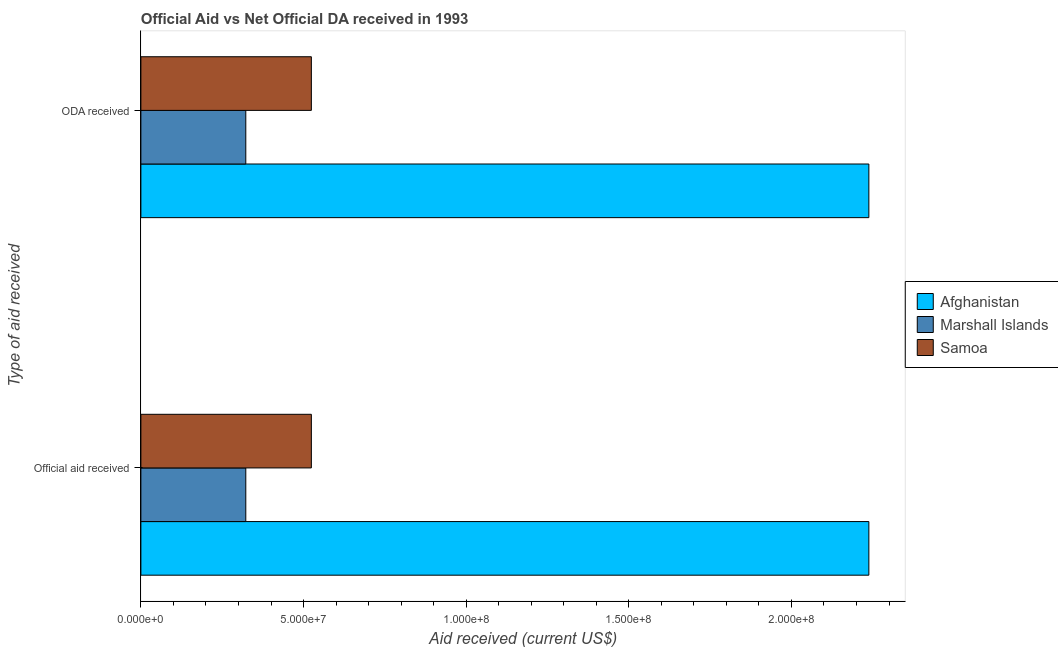How many different coloured bars are there?
Ensure brevity in your answer.  3. Are the number of bars per tick equal to the number of legend labels?
Your answer should be compact. Yes. How many bars are there on the 2nd tick from the bottom?
Ensure brevity in your answer.  3. What is the label of the 2nd group of bars from the top?
Your response must be concise. Official aid received. What is the oda received in Samoa?
Give a very brief answer. 5.24e+07. Across all countries, what is the maximum oda received?
Give a very brief answer. 2.24e+08. Across all countries, what is the minimum official aid received?
Ensure brevity in your answer.  3.22e+07. In which country was the oda received maximum?
Provide a succinct answer. Afghanistan. In which country was the oda received minimum?
Give a very brief answer. Marshall Islands. What is the total official aid received in the graph?
Ensure brevity in your answer.  3.08e+08. What is the difference between the official aid received in Marshall Islands and that in Afghanistan?
Your answer should be compact. -1.92e+08. What is the difference between the oda received in Afghanistan and the official aid received in Marshall Islands?
Your response must be concise. 1.92e+08. What is the average official aid received per country?
Your answer should be compact. 1.03e+08. What is the difference between the official aid received and oda received in Samoa?
Offer a very short reply. 0. In how many countries, is the oda received greater than 30000000 US$?
Provide a succinct answer. 3. What is the ratio of the official aid received in Marshall Islands to that in Afghanistan?
Give a very brief answer. 0.14. In how many countries, is the oda received greater than the average oda received taken over all countries?
Your answer should be very brief. 1. What does the 2nd bar from the top in Official aid received represents?
Your answer should be compact. Marshall Islands. What does the 1st bar from the bottom in ODA received represents?
Offer a very short reply. Afghanistan. How many bars are there?
Offer a very short reply. 6. Are all the bars in the graph horizontal?
Offer a very short reply. Yes. How many countries are there in the graph?
Provide a short and direct response. 3. Does the graph contain any zero values?
Your answer should be compact. No. Does the graph contain grids?
Offer a very short reply. No. Where does the legend appear in the graph?
Provide a short and direct response. Center right. What is the title of the graph?
Keep it short and to the point. Official Aid vs Net Official DA received in 1993 . What is the label or title of the X-axis?
Make the answer very short. Aid received (current US$). What is the label or title of the Y-axis?
Ensure brevity in your answer.  Type of aid received. What is the Aid received (current US$) of Afghanistan in Official aid received?
Provide a short and direct response. 2.24e+08. What is the Aid received (current US$) in Marshall Islands in Official aid received?
Offer a terse response. 3.22e+07. What is the Aid received (current US$) of Samoa in Official aid received?
Your answer should be compact. 5.24e+07. What is the Aid received (current US$) of Afghanistan in ODA received?
Your response must be concise. 2.24e+08. What is the Aid received (current US$) of Marshall Islands in ODA received?
Provide a short and direct response. 3.22e+07. What is the Aid received (current US$) in Samoa in ODA received?
Your response must be concise. 5.24e+07. Across all Type of aid received, what is the maximum Aid received (current US$) in Afghanistan?
Give a very brief answer. 2.24e+08. Across all Type of aid received, what is the maximum Aid received (current US$) of Marshall Islands?
Keep it short and to the point. 3.22e+07. Across all Type of aid received, what is the maximum Aid received (current US$) of Samoa?
Provide a succinct answer. 5.24e+07. Across all Type of aid received, what is the minimum Aid received (current US$) of Afghanistan?
Your response must be concise. 2.24e+08. Across all Type of aid received, what is the minimum Aid received (current US$) in Marshall Islands?
Give a very brief answer. 3.22e+07. Across all Type of aid received, what is the minimum Aid received (current US$) in Samoa?
Keep it short and to the point. 5.24e+07. What is the total Aid received (current US$) in Afghanistan in the graph?
Give a very brief answer. 4.48e+08. What is the total Aid received (current US$) of Marshall Islands in the graph?
Provide a succinct answer. 6.45e+07. What is the total Aid received (current US$) in Samoa in the graph?
Your response must be concise. 1.05e+08. What is the difference between the Aid received (current US$) in Afghanistan in Official aid received and that in ODA received?
Give a very brief answer. 0. What is the difference between the Aid received (current US$) in Samoa in Official aid received and that in ODA received?
Offer a terse response. 0. What is the difference between the Aid received (current US$) in Afghanistan in Official aid received and the Aid received (current US$) in Marshall Islands in ODA received?
Ensure brevity in your answer.  1.92e+08. What is the difference between the Aid received (current US$) of Afghanistan in Official aid received and the Aid received (current US$) of Samoa in ODA received?
Your answer should be compact. 1.71e+08. What is the difference between the Aid received (current US$) in Marshall Islands in Official aid received and the Aid received (current US$) in Samoa in ODA received?
Make the answer very short. -2.02e+07. What is the average Aid received (current US$) of Afghanistan per Type of aid received?
Make the answer very short. 2.24e+08. What is the average Aid received (current US$) of Marshall Islands per Type of aid received?
Offer a very short reply. 3.22e+07. What is the average Aid received (current US$) of Samoa per Type of aid received?
Offer a terse response. 5.24e+07. What is the difference between the Aid received (current US$) of Afghanistan and Aid received (current US$) of Marshall Islands in Official aid received?
Your answer should be compact. 1.92e+08. What is the difference between the Aid received (current US$) in Afghanistan and Aid received (current US$) in Samoa in Official aid received?
Ensure brevity in your answer.  1.71e+08. What is the difference between the Aid received (current US$) in Marshall Islands and Aid received (current US$) in Samoa in Official aid received?
Provide a succinct answer. -2.02e+07. What is the difference between the Aid received (current US$) of Afghanistan and Aid received (current US$) of Marshall Islands in ODA received?
Your response must be concise. 1.92e+08. What is the difference between the Aid received (current US$) of Afghanistan and Aid received (current US$) of Samoa in ODA received?
Your response must be concise. 1.71e+08. What is the difference between the Aid received (current US$) of Marshall Islands and Aid received (current US$) of Samoa in ODA received?
Offer a terse response. -2.02e+07. What is the ratio of the Aid received (current US$) of Afghanistan in Official aid received to that in ODA received?
Provide a succinct answer. 1. What is the difference between the highest and the second highest Aid received (current US$) in Marshall Islands?
Ensure brevity in your answer.  0. What is the difference between the highest and the second highest Aid received (current US$) in Samoa?
Provide a short and direct response. 0. What is the difference between the highest and the lowest Aid received (current US$) of Marshall Islands?
Provide a succinct answer. 0. What is the difference between the highest and the lowest Aid received (current US$) in Samoa?
Offer a very short reply. 0. 